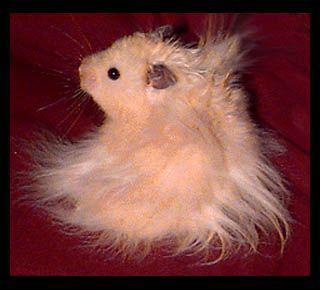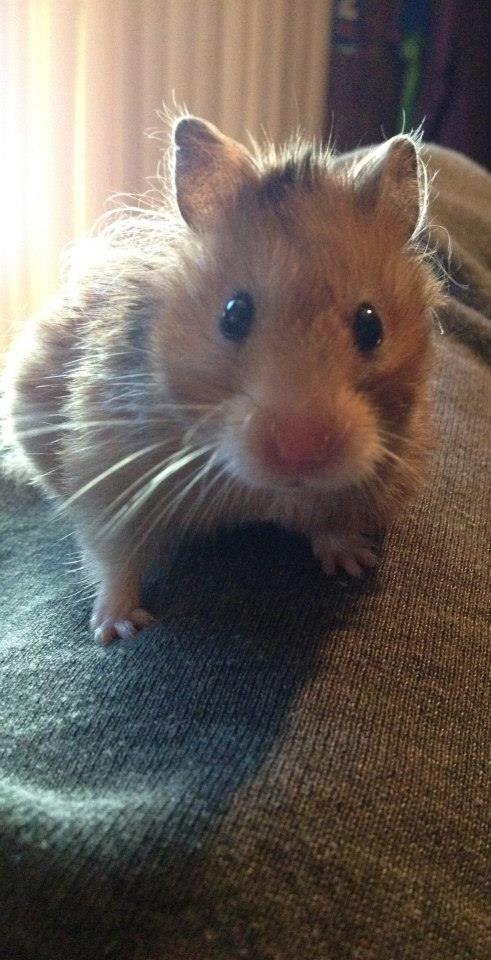The first image is the image on the left, the second image is the image on the right. Assess this claim about the two images: "In one image the hamster is held in someone's hand and in the other the hamster is standing on sawdust.". Correct or not? Answer yes or no. No. The first image is the image on the left, the second image is the image on the right. For the images shown, is this caption "A hamster is being held in someone's hand." true? Answer yes or no. No. The first image is the image on the left, the second image is the image on the right. Evaluate the accuracy of this statement regarding the images: "A human hand is holding a hamster in at least one of the images.". Is it true? Answer yes or no. No. The first image is the image on the left, the second image is the image on the right. Given the left and right images, does the statement "One outstretched palm holds a hamster that is standing and looking toward the camera." hold true? Answer yes or no. No. 